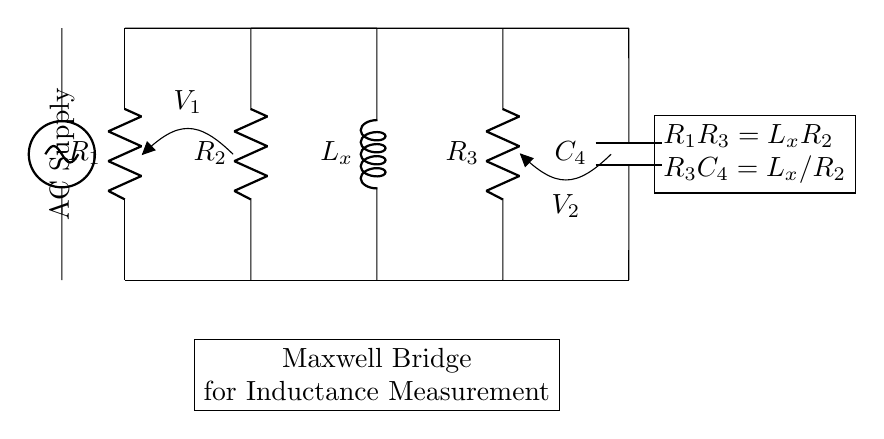What is the value of the inductor labeled in the circuit? The inductor is labeled as L_x, denoting that its value is unknown and needs to be measured.
Answer: L_x What components are in the Maxwell bridge circuit? The components include two resistors (R1 and R2), another resistor (R3), a capacitor (C4), and an inductor (L_x).
Answer: R1, R2, R3, C4, L_x What does the equation R1R3 equal in this circuit? The equation states that R1 multiplied by R3 equals the inductance L_x multiplied by R2, indicating a relationship necessary for balance in the bridge.
Answer: L_xR2 What type of bridge is represented in this circuit? The circuit is specifically a Maxwell bridge, which is used for measuring inductance.
Answer: Maxwell bridge What is the purpose of this circuit? The primary purpose is to measure the inductance of the inductor L_x by utilizing the balance concept in the bridge configuration.
Answer: Measure inductance What are the voltage labels in the circuit? There are two voltage labels: V1 across the resistors R1 and R2, and V2 across the capacitor C4 and resistor R3.
Answer: V1 and V2 What relationship does the equation R3C4 have with the inductor? The equation states that R3 multiplied by C4 equals the value of inductance L_x divided by R2, linking capacitance and resistance to inductance measurement.
Answer: L_x/R2 